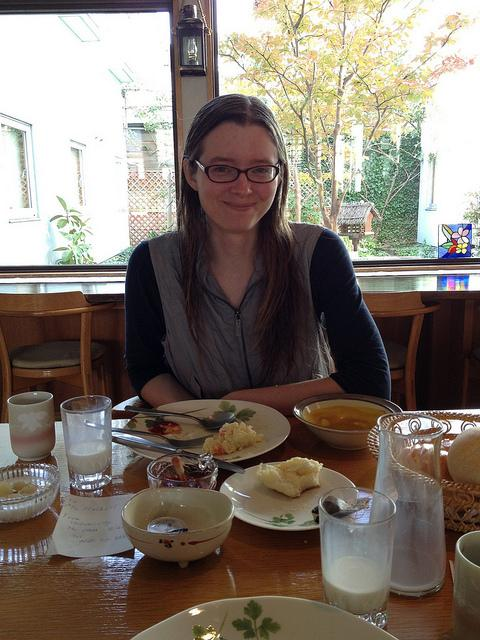How many people are likely enjoying this meal?

Choices:
A) two
B) seven
C) 12
D) 14 two 